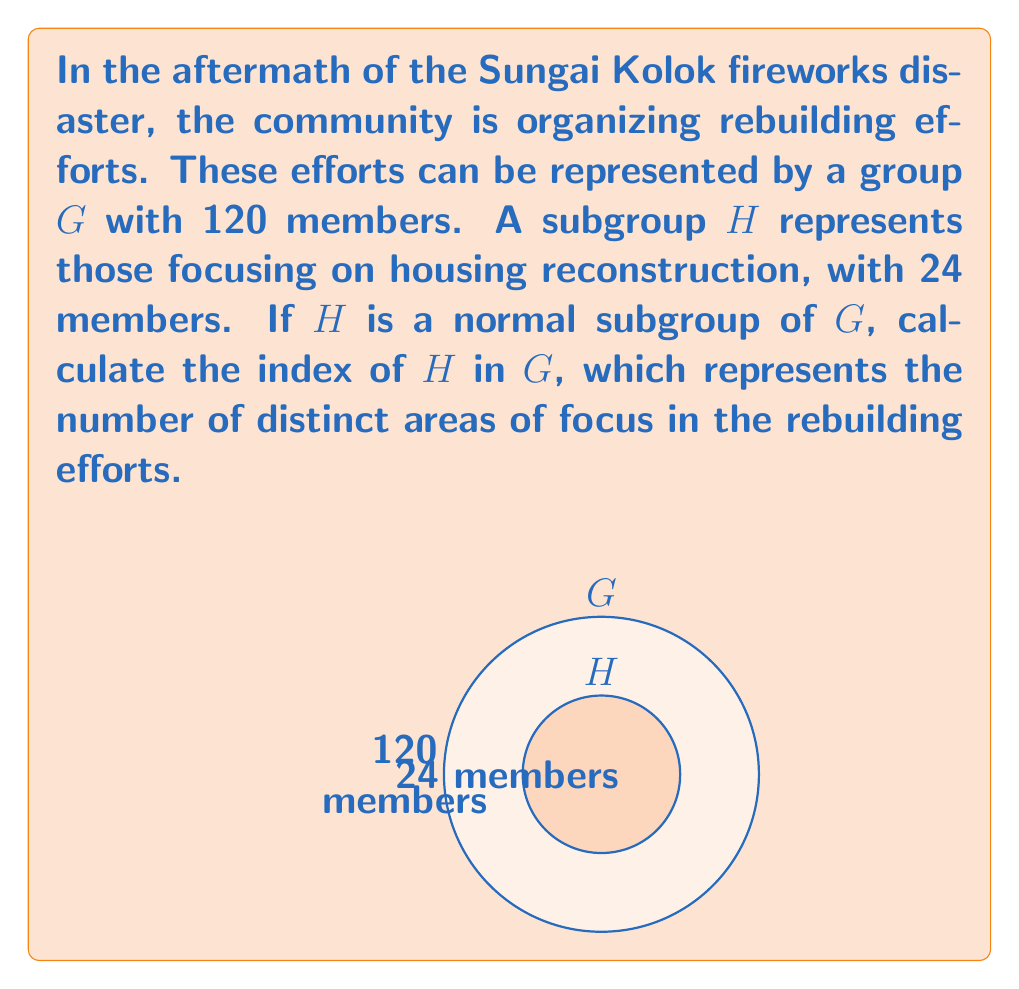Solve this math problem. To find the index of $H$ in $G$, we need to follow these steps:

1) Recall that the index of a subgroup $H$ in a group $G$ is denoted as $[G:H]$ and is defined as:

   $$[G:H] = \frac{|G|}{|H|}$$

   where $|G|$ is the order (number of elements) of $G$ and $|H|$ is the order of $H$.

2) We are given that:
   $|G| = 120$ (total members in the community rebuilding effort)
   $|H| = 24$ (members focusing on housing reconstruction)

3) Substituting these values into the formula:

   $$[G:H] = \frac{|G|}{|H|} = \frac{120}{24}$$

4) Simplify the fraction:
   $$\frac{120}{24} = 5$$

5) Therefore, the index of $H$ in $G$ is 5.

This means there are 5 distinct cosets of $H$ in $G$, which can be interpreted as 5 different areas of focus in the rebuilding efforts, including housing reconstruction.
Answer: $[G:H] = 5$ 